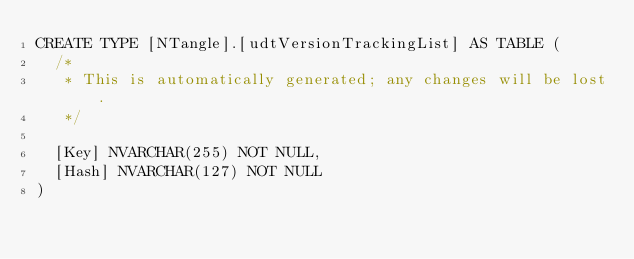Convert code to text. <code><loc_0><loc_0><loc_500><loc_500><_SQL_>CREATE TYPE [NTangle].[udtVersionTrackingList] AS TABLE (
  /*
   * This is automatically generated; any changes will be lost.
   */

  [Key] NVARCHAR(255) NOT NULL,
  [Hash] NVARCHAR(127) NOT NULL
)</code> 